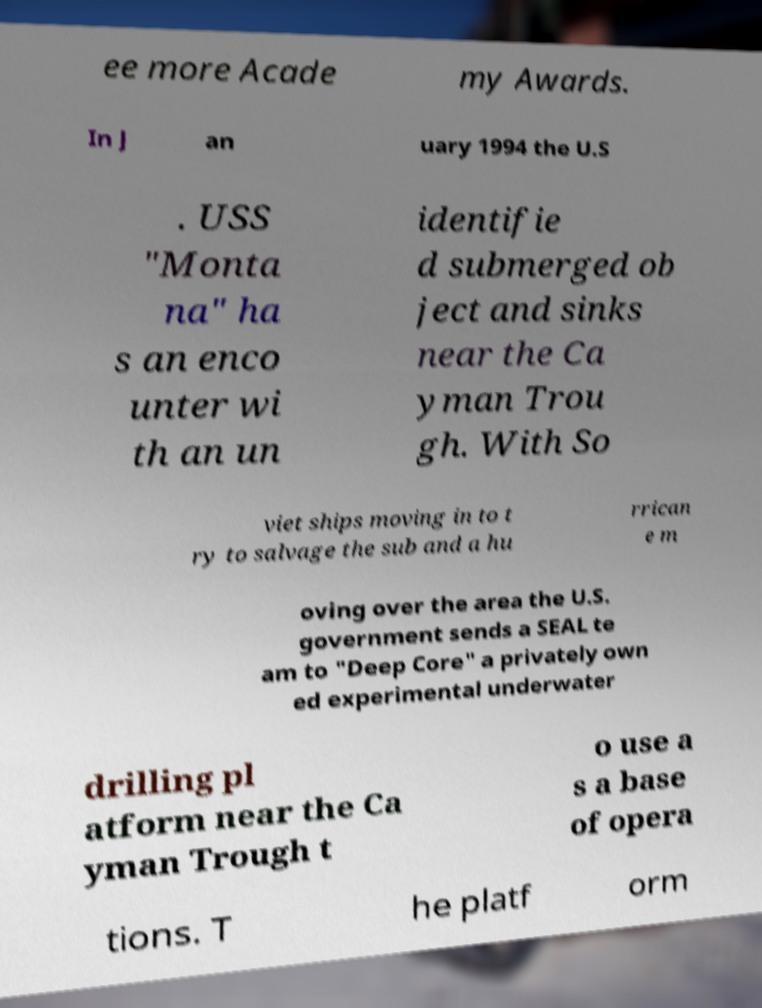Can you accurately transcribe the text from the provided image for me? ee more Acade my Awards. In J an uary 1994 the U.S . USS "Monta na" ha s an enco unter wi th an un identifie d submerged ob ject and sinks near the Ca yman Trou gh. With So viet ships moving in to t ry to salvage the sub and a hu rrican e m oving over the area the U.S. government sends a SEAL te am to "Deep Core" a privately own ed experimental underwater drilling pl atform near the Ca yman Trough t o use a s a base of opera tions. T he platf orm 